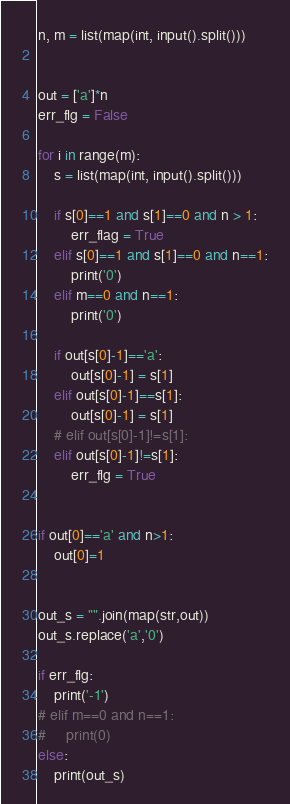Convert code to text. <code><loc_0><loc_0><loc_500><loc_500><_Python_>n, m = list(map(int, input().split()))

    
out = ['a']*n
err_flg = False

for i in range(m):
    s = list(map(int, input().split()))

    if s[0]==1 and s[1]==0 and n > 1:
        err_flag = True
    elif s[0]==1 and s[1]==0 and n==1:
        print('0')
    elif m==0 and n==1:
        print('0')

    if out[s[0]-1]=='a':
        out[s[0]-1] = s[1]
    elif out[s[0]-1]==s[1]:
        out[s[0]-1] = s[1]
    # elif out[s[0]-1]!=s[1]:
    elif out[s[0]-1]!=s[1]:
        err_flg = True


if out[0]=='a' and n>1:
    out[0]=1
    

out_s = "".join(map(str,out))
out_s.replace('a','0')

if err_flg:
    print('-1')
# elif m==0 and n==1:
#     print(0)
else:
    print(out_s)</code> 